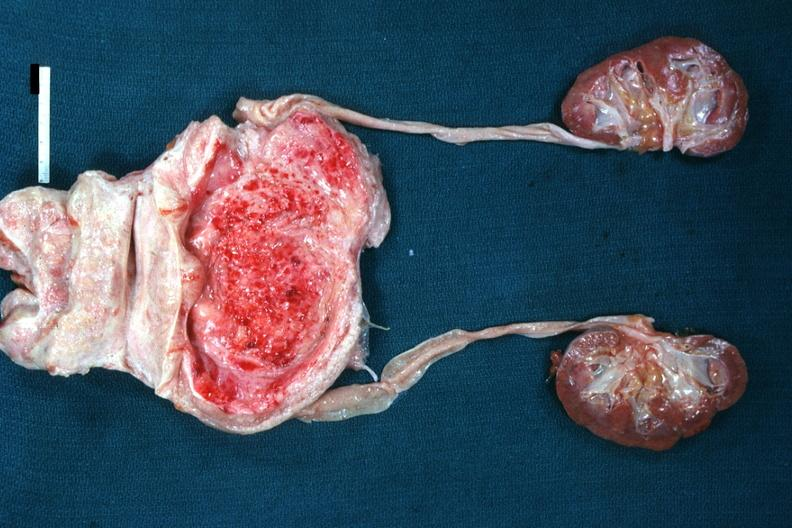what is present?
Answer the question using a single word or phrase. Prostate 